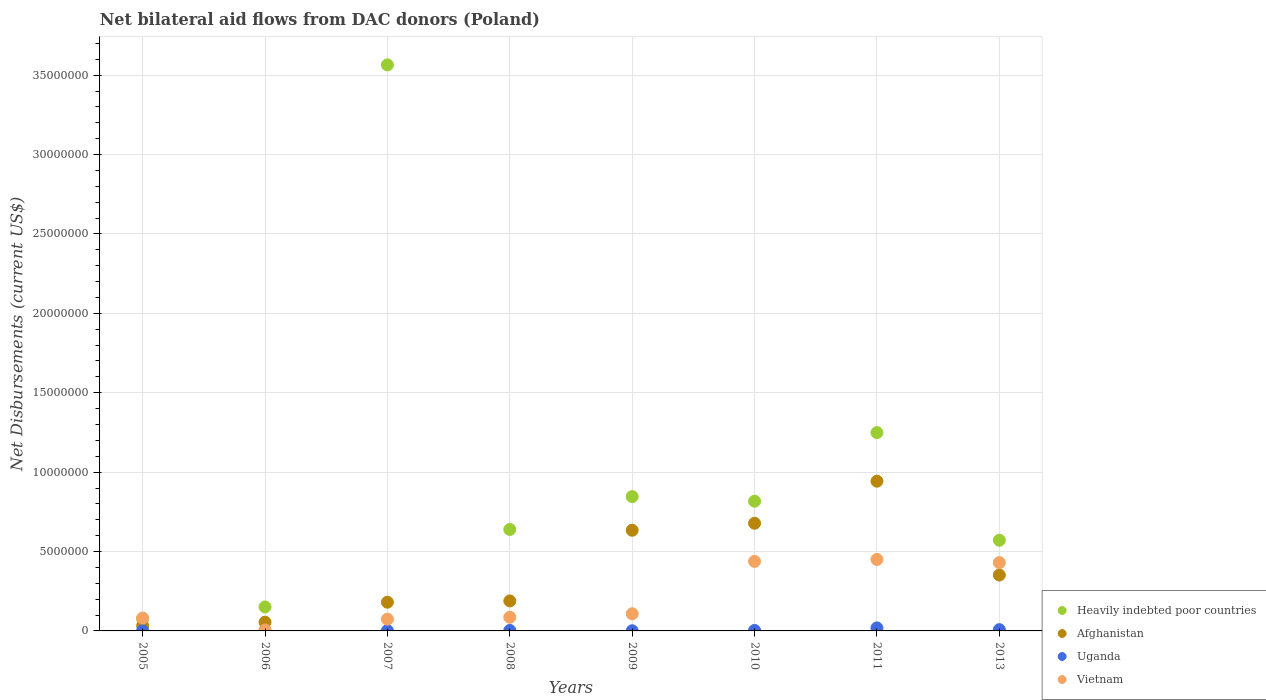Is the number of dotlines equal to the number of legend labels?
Keep it short and to the point. Yes. What is the net bilateral aid flows in Vietnam in 2010?
Ensure brevity in your answer.  4.38e+06. Across all years, what is the maximum net bilateral aid flows in Vietnam?
Offer a very short reply. 4.50e+06. Across all years, what is the minimum net bilateral aid flows in Afghanistan?
Make the answer very short. 3.30e+05. In which year was the net bilateral aid flows in Afghanistan maximum?
Ensure brevity in your answer.  2011. What is the total net bilateral aid flows in Vietnam in the graph?
Your response must be concise. 1.67e+07. What is the difference between the net bilateral aid flows in Uganda in 2011 and that in 2013?
Your answer should be very brief. 1.10e+05. What is the difference between the net bilateral aid flows in Afghanistan in 2011 and the net bilateral aid flows in Vietnam in 2007?
Make the answer very short. 8.69e+06. What is the average net bilateral aid flows in Afghanistan per year?
Offer a very short reply. 3.83e+06. In the year 2007, what is the difference between the net bilateral aid flows in Afghanistan and net bilateral aid flows in Vietnam?
Your response must be concise. 1.07e+06. What is the ratio of the net bilateral aid flows in Afghanistan in 2007 to that in 2008?
Your response must be concise. 0.96. Is the difference between the net bilateral aid flows in Afghanistan in 2008 and 2010 greater than the difference between the net bilateral aid flows in Vietnam in 2008 and 2010?
Keep it short and to the point. No. What is the difference between the highest and the second highest net bilateral aid flows in Uganda?
Keep it short and to the point. 1.10e+05. What is the difference between the highest and the lowest net bilateral aid flows in Uganda?
Your answer should be compact. 1.80e+05. Is it the case that in every year, the sum of the net bilateral aid flows in Uganda and net bilateral aid flows in Afghanistan  is greater than the sum of net bilateral aid flows in Heavily indebted poor countries and net bilateral aid flows in Vietnam?
Provide a short and direct response. No. Is it the case that in every year, the sum of the net bilateral aid flows in Heavily indebted poor countries and net bilateral aid flows in Afghanistan  is greater than the net bilateral aid flows in Uganda?
Keep it short and to the point. Yes. Does the net bilateral aid flows in Heavily indebted poor countries monotonically increase over the years?
Your response must be concise. No. Is the net bilateral aid flows in Vietnam strictly greater than the net bilateral aid flows in Uganda over the years?
Your answer should be very brief. Yes. How many dotlines are there?
Keep it short and to the point. 4. What is the difference between two consecutive major ticks on the Y-axis?
Your response must be concise. 5.00e+06. Are the values on the major ticks of Y-axis written in scientific E-notation?
Your response must be concise. No. Does the graph contain grids?
Your answer should be compact. Yes. Where does the legend appear in the graph?
Your answer should be compact. Bottom right. How are the legend labels stacked?
Provide a succinct answer. Vertical. What is the title of the graph?
Offer a very short reply. Net bilateral aid flows from DAC donors (Poland). What is the label or title of the X-axis?
Provide a short and direct response. Years. What is the label or title of the Y-axis?
Offer a terse response. Net Disbursements (current US$). What is the Net Disbursements (current US$) of Heavily indebted poor countries in 2005?
Make the answer very short. 7.60e+05. What is the Net Disbursements (current US$) in Afghanistan in 2005?
Your answer should be compact. 3.30e+05. What is the Net Disbursements (current US$) of Uganda in 2005?
Offer a very short reply. 10000. What is the Net Disbursements (current US$) in Vietnam in 2005?
Offer a very short reply. 8.10e+05. What is the Net Disbursements (current US$) of Heavily indebted poor countries in 2006?
Your response must be concise. 1.51e+06. What is the Net Disbursements (current US$) in Uganda in 2006?
Your answer should be very brief. 10000. What is the Net Disbursements (current US$) of Vietnam in 2006?
Provide a succinct answer. 6.00e+04. What is the Net Disbursements (current US$) in Heavily indebted poor countries in 2007?
Ensure brevity in your answer.  3.56e+07. What is the Net Disbursements (current US$) in Afghanistan in 2007?
Your response must be concise. 1.81e+06. What is the Net Disbursements (current US$) in Uganda in 2007?
Offer a terse response. 2.00e+04. What is the Net Disbursements (current US$) in Vietnam in 2007?
Provide a short and direct response. 7.40e+05. What is the Net Disbursements (current US$) of Heavily indebted poor countries in 2008?
Provide a short and direct response. 6.39e+06. What is the Net Disbursements (current US$) of Afghanistan in 2008?
Provide a short and direct response. 1.89e+06. What is the Net Disbursements (current US$) in Uganda in 2008?
Your response must be concise. 3.00e+04. What is the Net Disbursements (current US$) in Vietnam in 2008?
Provide a short and direct response. 8.60e+05. What is the Net Disbursements (current US$) of Heavily indebted poor countries in 2009?
Your response must be concise. 8.46e+06. What is the Net Disbursements (current US$) in Afghanistan in 2009?
Offer a terse response. 6.34e+06. What is the Net Disbursements (current US$) of Uganda in 2009?
Your answer should be very brief. 10000. What is the Net Disbursements (current US$) of Vietnam in 2009?
Provide a succinct answer. 1.08e+06. What is the Net Disbursements (current US$) of Heavily indebted poor countries in 2010?
Ensure brevity in your answer.  8.17e+06. What is the Net Disbursements (current US$) in Afghanistan in 2010?
Your answer should be very brief. 6.78e+06. What is the Net Disbursements (current US$) of Uganda in 2010?
Provide a short and direct response. 3.00e+04. What is the Net Disbursements (current US$) in Vietnam in 2010?
Your response must be concise. 4.38e+06. What is the Net Disbursements (current US$) of Heavily indebted poor countries in 2011?
Offer a terse response. 1.25e+07. What is the Net Disbursements (current US$) of Afghanistan in 2011?
Offer a terse response. 9.43e+06. What is the Net Disbursements (current US$) in Uganda in 2011?
Offer a very short reply. 1.90e+05. What is the Net Disbursements (current US$) of Vietnam in 2011?
Your answer should be compact. 4.50e+06. What is the Net Disbursements (current US$) in Heavily indebted poor countries in 2013?
Offer a terse response. 5.71e+06. What is the Net Disbursements (current US$) of Afghanistan in 2013?
Provide a short and direct response. 3.52e+06. What is the Net Disbursements (current US$) of Vietnam in 2013?
Your response must be concise. 4.30e+06. Across all years, what is the maximum Net Disbursements (current US$) of Heavily indebted poor countries?
Offer a very short reply. 3.56e+07. Across all years, what is the maximum Net Disbursements (current US$) in Afghanistan?
Give a very brief answer. 9.43e+06. Across all years, what is the maximum Net Disbursements (current US$) in Vietnam?
Make the answer very short. 4.50e+06. Across all years, what is the minimum Net Disbursements (current US$) of Heavily indebted poor countries?
Provide a succinct answer. 7.60e+05. Across all years, what is the minimum Net Disbursements (current US$) in Uganda?
Ensure brevity in your answer.  10000. Across all years, what is the minimum Net Disbursements (current US$) in Vietnam?
Offer a terse response. 6.00e+04. What is the total Net Disbursements (current US$) in Heavily indebted poor countries in the graph?
Your answer should be compact. 7.91e+07. What is the total Net Disbursements (current US$) in Afghanistan in the graph?
Ensure brevity in your answer.  3.06e+07. What is the total Net Disbursements (current US$) of Uganda in the graph?
Provide a short and direct response. 3.80e+05. What is the total Net Disbursements (current US$) in Vietnam in the graph?
Give a very brief answer. 1.67e+07. What is the difference between the Net Disbursements (current US$) in Heavily indebted poor countries in 2005 and that in 2006?
Provide a short and direct response. -7.50e+05. What is the difference between the Net Disbursements (current US$) in Uganda in 2005 and that in 2006?
Provide a short and direct response. 0. What is the difference between the Net Disbursements (current US$) of Vietnam in 2005 and that in 2006?
Your response must be concise. 7.50e+05. What is the difference between the Net Disbursements (current US$) in Heavily indebted poor countries in 2005 and that in 2007?
Your response must be concise. -3.49e+07. What is the difference between the Net Disbursements (current US$) of Afghanistan in 2005 and that in 2007?
Provide a succinct answer. -1.48e+06. What is the difference between the Net Disbursements (current US$) in Heavily indebted poor countries in 2005 and that in 2008?
Offer a very short reply. -5.63e+06. What is the difference between the Net Disbursements (current US$) of Afghanistan in 2005 and that in 2008?
Give a very brief answer. -1.56e+06. What is the difference between the Net Disbursements (current US$) of Heavily indebted poor countries in 2005 and that in 2009?
Offer a terse response. -7.70e+06. What is the difference between the Net Disbursements (current US$) of Afghanistan in 2005 and that in 2009?
Your answer should be compact. -6.01e+06. What is the difference between the Net Disbursements (current US$) in Uganda in 2005 and that in 2009?
Provide a short and direct response. 0. What is the difference between the Net Disbursements (current US$) in Vietnam in 2005 and that in 2009?
Offer a very short reply. -2.70e+05. What is the difference between the Net Disbursements (current US$) of Heavily indebted poor countries in 2005 and that in 2010?
Your answer should be compact. -7.41e+06. What is the difference between the Net Disbursements (current US$) in Afghanistan in 2005 and that in 2010?
Provide a succinct answer. -6.45e+06. What is the difference between the Net Disbursements (current US$) of Vietnam in 2005 and that in 2010?
Provide a short and direct response. -3.57e+06. What is the difference between the Net Disbursements (current US$) in Heavily indebted poor countries in 2005 and that in 2011?
Your response must be concise. -1.17e+07. What is the difference between the Net Disbursements (current US$) in Afghanistan in 2005 and that in 2011?
Keep it short and to the point. -9.10e+06. What is the difference between the Net Disbursements (current US$) in Uganda in 2005 and that in 2011?
Give a very brief answer. -1.80e+05. What is the difference between the Net Disbursements (current US$) in Vietnam in 2005 and that in 2011?
Keep it short and to the point. -3.69e+06. What is the difference between the Net Disbursements (current US$) in Heavily indebted poor countries in 2005 and that in 2013?
Make the answer very short. -4.95e+06. What is the difference between the Net Disbursements (current US$) of Afghanistan in 2005 and that in 2013?
Keep it short and to the point. -3.19e+06. What is the difference between the Net Disbursements (current US$) of Vietnam in 2005 and that in 2013?
Your answer should be very brief. -3.49e+06. What is the difference between the Net Disbursements (current US$) of Heavily indebted poor countries in 2006 and that in 2007?
Make the answer very short. -3.41e+07. What is the difference between the Net Disbursements (current US$) in Afghanistan in 2006 and that in 2007?
Make the answer very short. -1.26e+06. What is the difference between the Net Disbursements (current US$) in Vietnam in 2006 and that in 2007?
Your response must be concise. -6.80e+05. What is the difference between the Net Disbursements (current US$) of Heavily indebted poor countries in 2006 and that in 2008?
Offer a very short reply. -4.88e+06. What is the difference between the Net Disbursements (current US$) in Afghanistan in 2006 and that in 2008?
Provide a succinct answer. -1.34e+06. What is the difference between the Net Disbursements (current US$) in Vietnam in 2006 and that in 2008?
Offer a terse response. -8.00e+05. What is the difference between the Net Disbursements (current US$) of Heavily indebted poor countries in 2006 and that in 2009?
Make the answer very short. -6.95e+06. What is the difference between the Net Disbursements (current US$) of Afghanistan in 2006 and that in 2009?
Your answer should be compact. -5.79e+06. What is the difference between the Net Disbursements (current US$) in Uganda in 2006 and that in 2009?
Your response must be concise. 0. What is the difference between the Net Disbursements (current US$) in Vietnam in 2006 and that in 2009?
Your answer should be compact. -1.02e+06. What is the difference between the Net Disbursements (current US$) of Heavily indebted poor countries in 2006 and that in 2010?
Offer a very short reply. -6.66e+06. What is the difference between the Net Disbursements (current US$) in Afghanistan in 2006 and that in 2010?
Offer a very short reply. -6.23e+06. What is the difference between the Net Disbursements (current US$) of Uganda in 2006 and that in 2010?
Offer a very short reply. -2.00e+04. What is the difference between the Net Disbursements (current US$) in Vietnam in 2006 and that in 2010?
Your answer should be very brief. -4.32e+06. What is the difference between the Net Disbursements (current US$) of Heavily indebted poor countries in 2006 and that in 2011?
Your answer should be very brief. -1.10e+07. What is the difference between the Net Disbursements (current US$) of Afghanistan in 2006 and that in 2011?
Keep it short and to the point. -8.88e+06. What is the difference between the Net Disbursements (current US$) of Vietnam in 2006 and that in 2011?
Your answer should be very brief. -4.44e+06. What is the difference between the Net Disbursements (current US$) of Heavily indebted poor countries in 2006 and that in 2013?
Offer a very short reply. -4.20e+06. What is the difference between the Net Disbursements (current US$) in Afghanistan in 2006 and that in 2013?
Ensure brevity in your answer.  -2.97e+06. What is the difference between the Net Disbursements (current US$) of Vietnam in 2006 and that in 2013?
Make the answer very short. -4.24e+06. What is the difference between the Net Disbursements (current US$) of Heavily indebted poor countries in 2007 and that in 2008?
Your answer should be compact. 2.93e+07. What is the difference between the Net Disbursements (current US$) in Afghanistan in 2007 and that in 2008?
Keep it short and to the point. -8.00e+04. What is the difference between the Net Disbursements (current US$) of Uganda in 2007 and that in 2008?
Keep it short and to the point. -10000. What is the difference between the Net Disbursements (current US$) in Vietnam in 2007 and that in 2008?
Provide a succinct answer. -1.20e+05. What is the difference between the Net Disbursements (current US$) in Heavily indebted poor countries in 2007 and that in 2009?
Your answer should be compact. 2.72e+07. What is the difference between the Net Disbursements (current US$) of Afghanistan in 2007 and that in 2009?
Keep it short and to the point. -4.53e+06. What is the difference between the Net Disbursements (current US$) in Uganda in 2007 and that in 2009?
Your answer should be very brief. 10000. What is the difference between the Net Disbursements (current US$) in Heavily indebted poor countries in 2007 and that in 2010?
Offer a very short reply. 2.75e+07. What is the difference between the Net Disbursements (current US$) of Afghanistan in 2007 and that in 2010?
Provide a short and direct response. -4.97e+06. What is the difference between the Net Disbursements (current US$) of Vietnam in 2007 and that in 2010?
Provide a succinct answer. -3.64e+06. What is the difference between the Net Disbursements (current US$) in Heavily indebted poor countries in 2007 and that in 2011?
Provide a short and direct response. 2.32e+07. What is the difference between the Net Disbursements (current US$) of Afghanistan in 2007 and that in 2011?
Provide a short and direct response. -7.62e+06. What is the difference between the Net Disbursements (current US$) of Uganda in 2007 and that in 2011?
Your answer should be compact. -1.70e+05. What is the difference between the Net Disbursements (current US$) in Vietnam in 2007 and that in 2011?
Your response must be concise. -3.76e+06. What is the difference between the Net Disbursements (current US$) of Heavily indebted poor countries in 2007 and that in 2013?
Provide a succinct answer. 2.99e+07. What is the difference between the Net Disbursements (current US$) of Afghanistan in 2007 and that in 2013?
Offer a very short reply. -1.71e+06. What is the difference between the Net Disbursements (current US$) in Vietnam in 2007 and that in 2013?
Give a very brief answer. -3.56e+06. What is the difference between the Net Disbursements (current US$) of Heavily indebted poor countries in 2008 and that in 2009?
Your answer should be very brief. -2.07e+06. What is the difference between the Net Disbursements (current US$) in Afghanistan in 2008 and that in 2009?
Provide a succinct answer. -4.45e+06. What is the difference between the Net Disbursements (current US$) in Uganda in 2008 and that in 2009?
Ensure brevity in your answer.  2.00e+04. What is the difference between the Net Disbursements (current US$) of Heavily indebted poor countries in 2008 and that in 2010?
Your answer should be compact. -1.78e+06. What is the difference between the Net Disbursements (current US$) of Afghanistan in 2008 and that in 2010?
Give a very brief answer. -4.89e+06. What is the difference between the Net Disbursements (current US$) in Uganda in 2008 and that in 2010?
Offer a terse response. 0. What is the difference between the Net Disbursements (current US$) of Vietnam in 2008 and that in 2010?
Ensure brevity in your answer.  -3.52e+06. What is the difference between the Net Disbursements (current US$) of Heavily indebted poor countries in 2008 and that in 2011?
Your answer should be very brief. -6.10e+06. What is the difference between the Net Disbursements (current US$) of Afghanistan in 2008 and that in 2011?
Offer a terse response. -7.54e+06. What is the difference between the Net Disbursements (current US$) in Uganda in 2008 and that in 2011?
Provide a succinct answer. -1.60e+05. What is the difference between the Net Disbursements (current US$) of Vietnam in 2008 and that in 2011?
Your answer should be compact. -3.64e+06. What is the difference between the Net Disbursements (current US$) in Heavily indebted poor countries in 2008 and that in 2013?
Your answer should be compact. 6.80e+05. What is the difference between the Net Disbursements (current US$) in Afghanistan in 2008 and that in 2013?
Your answer should be compact. -1.63e+06. What is the difference between the Net Disbursements (current US$) of Uganda in 2008 and that in 2013?
Give a very brief answer. -5.00e+04. What is the difference between the Net Disbursements (current US$) in Vietnam in 2008 and that in 2013?
Your response must be concise. -3.44e+06. What is the difference between the Net Disbursements (current US$) of Afghanistan in 2009 and that in 2010?
Keep it short and to the point. -4.40e+05. What is the difference between the Net Disbursements (current US$) in Uganda in 2009 and that in 2010?
Your answer should be compact. -2.00e+04. What is the difference between the Net Disbursements (current US$) of Vietnam in 2009 and that in 2010?
Give a very brief answer. -3.30e+06. What is the difference between the Net Disbursements (current US$) in Heavily indebted poor countries in 2009 and that in 2011?
Give a very brief answer. -4.03e+06. What is the difference between the Net Disbursements (current US$) of Afghanistan in 2009 and that in 2011?
Keep it short and to the point. -3.09e+06. What is the difference between the Net Disbursements (current US$) of Vietnam in 2009 and that in 2011?
Your answer should be compact. -3.42e+06. What is the difference between the Net Disbursements (current US$) in Heavily indebted poor countries in 2009 and that in 2013?
Provide a short and direct response. 2.75e+06. What is the difference between the Net Disbursements (current US$) of Afghanistan in 2009 and that in 2013?
Keep it short and to the point. 2.82e+06. What is the difference between the Net Disbursements (current US$) in Uganda in 2009 and that in 2013?
Your answer should be very brief. -7.00e+04. What is the difference between the Net Disbursements (current US$) of Vietnam in 2009 and that in 2013?
Keep it short and to the point. -3.22e+06. What is the difference between the Net Disbursements (current US$) of Heavily indebted poor countries in 2010 and that in 2011?
Your answer should be compact. -4.32e+06. What is the difference between the Net Disbursements (current US$) of Afghanistan in 2010 and that in 2011?
Offer a terse response. -2.65e+06. What is the difference between the Net Disbursements (current US$) in Heavily indebted poor countries in 2010 and that in 2013?
Provide a succinct answer. 2.46e+06. What is the difference between the Net Disbursements (current US$) in Afghanistan in 2010 and that in 2013?
Your answer should be compact. 3.26e+06. What is the difference between the Net Disbursements (current US$) in Vietnam in 2010 and that in 2013?
Ensure brevity in your answer.  8.00e+04. What is the difference between the Net Disbursements (current US$) in Heavily indebted poor countries in 2011 and that in 2013?
Provide a short and direct response. 6.78e+06. What is the difference between the Net Disbursements (current US$) in Afghanistan in 2011 and that in 2013?
Offer a terse response. 5.91e+06. What is the difference between the Net Disbursements (current US$) in Uganda in 2011 and that in 2013?
Give a very brief answer. 1.10e+05. What is the difference between the Net Disbursements (current US$) in Vietnam in 2011 and that in 2013?
Your response must be concise. 2.00e+05. What is the difference between the Net Disbursements (current US$) of Heavily indebted poor countries in 2005 and the Net Disbursements (current US$) of Uganda in 2006?
Offer a terse response. 7.50e+05. What is the difference between the Net Disbursements (current US$) of Heavily indebted poor countries in 2005 and the Net Disbursements (current US$) of Afghanistan in 2007?
Your answer should be very brief. -1.05e+06. What is the difference between the Net Disbursements (current US$) of Heavily indebted poor countries in 2005 and the Net Disbursements (current US$) of Uganda in 2007?
Give a very brief answer. 7.40e+05. What is the difference between the Net Disbursements (current US$) in Heavily indebted poor countries in 2005 and the Net Disbursements (current US$) in Vietnam in 2007?
Provide a succinct answer. 2.00e+04. What is the difference between the Net Disbursements (current US$) of Afghanistan in 2005 and the Net Disbursements (current US$) of Uganda in 2007?
Give a very brief answer. 3.10e+05. What is the difference between the Net Disbursements (current US$) of Afghanistan in 2005 and the Net Disbursements (current US$) of Vietnam in 2007?
Offer a very short reply. -4.10e+05. What is the difference between the Net Disbursements (current US$) in Uganda in 2005 and the Net Disbursements (current US$) in Vietnam in 2007?
Your answer should be very brief. -7.30e+05. What is the difference between the Net Disbursements (current US$) of Heavily indebted poor countries in 2005 and the Net Disbursements (current US$) of Afghanistan in 2008?
Offer a very short reply. -1.13e+06. What is the difference between the Net Disbursements (current US$) of Heavily indebted poor countries in 2005 and the Net Disbursements (current US$) of Uganda in 2008?
Ensure brevity in your answer.  7.30e+05. What is the difference between the Net Disbursements (current US$) of Heavily indebted poor countries in 2005 and the Net Disbursements (current US$) of Vietnam in 2008?
Your answer should be compact. -1.00e+05. What is the difference between the Net Disbursements (current US$) in Afghanistan in 2005 and the Net Disbursements (current US$) in Uganda in 2008?
Offer a terse response. 3.00e+05. What is the difference between the Net Disbursements (current US$) of Afghanistan in 2005 and the Net Disbursements (current US$) of Vietnam in 2008?
Ensure brevity in your answer.  -5.30e+05. What is the difference between the Net Disbursements (current US$) in Uganda in 2005 and the Net Disbursements (current US$) in Vietnam in 2008?
Offer a terse response. -8.50e+05. What is the difference between the Net Disbursements (current US$) of Heavily indebted poor countries in 2005 and the Net Disbursements (current US$) of Afghanistan in 2009?
Provide a succinct answer. -5.58e+06. What is the difference between the Net Disbursements (current US$) in Heavily indebted poor countries in 2005 and the Net Disbursements (current US$) in Uganda in 2009?
Your answer should be compact. 7.50e+05. What is the difference between the Net Disbursements (current US$) in Heavily indebted poor countries in 2005 and the Net Disbursements (current US$) in Vietnam in 2009?
Give a very brief answer. -3.20e+05. What is the difference between the Net Disbursements (current US$) of Afghanistan in 2005 and the Net Disbursements (current US$) of Vietnam in 2009?
Ensure brevity in your answer.  -7.50e+05. What is the difference between the Net Disbursements (current US$) in Uganda in 2005 and the Net Disbursements (current US$) in Vietnam in 2009?
Ensure brevity in your answer.  -1.07e+06. What is the difference between the Net Disbursements (current US$) in Heavily indebted poor countries in 2005 and the Net Disbursements (current US$) in Afghanistan in 2010?
Make the answer very short. -6.02e+06. What is the difference between the Net Disbursements (current US$) in Heavily indebted poor countries in 2005 and the Net Disbursements (current US$) in Uganda in 2010?
Offer a very short reply. 7.30e+05. What is the difference between the Net Disbursements (current US$) of Heavily indebted poor countries in 2005 and the Net Disbursements (current US$) of Vietnam in 2010?
Your response must be concise. -3.62e+06. What is the difference between the Net Disbursements (current US$) in Afghanistan in 2005 and the Net Disbursements (current US$) in Uganda in 2010?
Provide a short and direct response. 3.00e+05. What is the difference between the Net Disbursements (current US$) in Afghanistan in 2005 and the Net Disbursements (current US$) in Vietnam in 2010?
Keep it short and to the point. -4.05e+06. What is the difference between the Net Disbursements (current US$) of Uganda in 2005 and the Net Disbursements (current US$) of Vietnam in 2010?
Offer a terse response. -4.37e+06. What is the difference between the Net Disbursements (current US$) of Heavily indebted poor countries in 2005 and the Net Disbursements (current US$) of Afghanistan in 2011?
Your answer should be compact. -8.67e+06. What is the difference between the Net Disbursements (current US$) of Heavily indebted poor countries in 2005 and the Net Disbursements (current US$) of Uganda in 2011?
Give a very brief answer. 5.70e+05. What is the difference between the Net Disbursements (current US$) in Heavily indebted poor countries in 2005 and the Net Disbursements (current US$) in Vietnam in 2011?
Your answer should be compact. -3.74e+06. What is the difference between the Net Disbursements (current US$) of Afghanistan in 2005 and the Net Disbursements (current US$) of Vietnam in 2011?
Offer a terse response. -4.17e+06. What is the difference between the Net Disbursements (current US$) in Uganda in 2005 and the Net Disbursements (current US$) in Vietnam in 2011?
Ensure brevity in your answer.  -4.49e+06. What is the difference between the Net Disbursements (current US$) in Heavily indebted poor countries in 2005 and the Net Disbursements (current US$) in Afghanistan in 2013?
Give a very brief answer. -2.76e+06. What is the difference between the Net Disbursements (current US$) of Heavily indebted poor countries in 2005 and the Net Disbursements (current US$) of Uganda in 2013?
Provide a short and direct response. 6.80e+05. What is the difference between the Net Disbursements (current US$) in Heavily indebted poor countries in 2005 and the Net Disbursements (current US$) in Vietnam in 2013?
Keep it short and to the point. -3.54e+06. What is the difference between the Net Disbursements (current US$) in Afghanistan in 2005 and the Net Disbursements (current US$) in Vietnam in 2013?
Your response must be concise. -3.97e+06. What is the difference between the Net Disbursements (current US$) of Uganda in 2005 and the Net Disbursements (current US$) of Vietnam in 2013?
Your response must be concise. -4.29e+06. What is the difference between the Net Disbursements (current US$) of Heavily indebted poor countries in 2006 and the Net Disbursements (current US$) of Afghanistan in 2007?
Your answer should be compact. -3.00e+05. What is the difference between the Net Disbursements (current US$) in Heavily indebted poor countries in 2006 and the Net Disbursements (current US$) in Uganda in 2007?
Offer a terse response. 1.49e+06. What is the difference between the Net Disbursements (current US$) in Heavily indebted poor countries in 2006 and the Net Disbursements (current US$) in Vietnam in 2007?
Ensure brevity in your answer.  7.70e+05. What is the difference between the Net Disbursements (current US$) in Afghanistan in 2006 and the Net Disbursements (current US$) in Uganda in 2007?
Ensure brevity in your answer.  5.30e+05. What is the difference between the Net Disbursements (current US$) of Uganda in 2006 and the Net Disbursements (current US$) of Vietnam in 2007?
Your answer should be compact. -7.30e+05. What is the difference between the Net Disbursements (current US$) in Heavily indebted poor countries in 2006 and the Net Disbursements (current US$) in Afghanistan in 2008?
Provide a succinct answer. -3.80e+05. What is the difference between the Net Disbursements (current US$) in Heavily indebted poor countries in 2006 and the Net Disbursements (current US$) in Uganda in 2008?
Your answer should be very brief. 1.48e+06. What is the difference between the Net Disbursements (current US$) in Heavily indebted poor countries in 2006 and the Net Disbursements (current US$) in Vietnam in 2008?
Offer a terse response. 6.50e+05. What is the difference between the Net Disbursements (current US$) in Afghanistan in 2006 and the Net Disbursements (current US$) in Uganda in 2008?
Your answer should be very brief. 5.20e+05. What is the difference between the Net Disbursements (current US$) in Afghanistan in 2006 and the Net Disbursements (current US$) in Vietnam in 2008?
Offer a very short reply. -3.10e+05. What is the difference between the Net Disbursements (current US$) in Uganda in 2006 and the Net Disbursements (current US$) in Vietnam in 2008?
Your answer should be very brief. -8.50e+05. What is the difference between the Net Disbursements (current US$) of Heavily indebted poor countries in 2006 and the Net Disbursements (current US$) of Afghanistan in 2009?
Give a very brief answer. -4.83e+06. What is the difference between the Net Disbursements (current US$) of Heavily indebted poor countries in 2006 and the Net Disbursements (current US$) of Uganda in 2009?
Offer a terse response. 1.50e+06. What is the difference between the Net Disbursements (current US$) in Heavily indebted poor countries in 2006 and the Net Disbursements (current US$) in Vietnam in 2009?
Give a very brief answer. 4.30e+05. What is the difference between the Net Disbursements (current US$) in Afghanistan in 2006 and the Net Disbursements (current US$) in Uganda in 2009?
Make the answer very short. 5.40e+05. What is the difference between the Net Disbursements (current US$) in Afghanistan in 2006 and the Net Disbursements (current US$) in Vietnam in 2009?
Your answer should be very brief. -5.30e+05. What is the difference between the Net Disbursements (current US$) of Uganda in 2006 and the Net Disbursements (current US$) of Vietnam in 2009?
Make the answer very short. -1.07e+06. What is the difference between the Net Disbursements (current US$) of Heavily indebted poor countries in 2006 and the Net Disbursements (current US$) of Afghanistan in 2010?
Make the answer very short. -5.27e+06. What is the difference between the Net Disbursements (current US$) in Heavily indebted poor countries in 2006 and the Net Disbursements (current US$) in Uganda in 2010?
Offer a very short reply. 1.48e+06. What is the difference between the Net Disbursements (current US$) in Heavily indebted poor countries in 2006 and the Net Disbursements (current US$) in Vietnam in 2010?
Make the answer very short. -2.87e+06. What is the difference between the Net Disbursements (current US$) of Afghanistan in 2006 and the Net Disbursements (current US$) of Uganda in 2010?
Provide a succinct answer. 5.20e+05. What is the difference between the Net Disbursements (current US$) in Afghanistan in 2006 and the Net Disbursements (current US$) in Vietnam in 2010?
Provide a short and direct response. -3.83e+06. What is the difference between the Net Disbursements (current US$) in Uganda in 2006 and the Net Disbursements (current US$) in Vietnam in 2010?
Keep it short and to the point. -4.37e+06. What is the difference between the Net Disbursements (current US$) of Heavily indebted poor countries in 2006 and the Net Disbursements (current US$) of Afghanistan in 2011?
Provide a succinct answer. -7.92e+06. What is the difference between the Net Disbursements (current US$) of Heavily indebted poor countries in 2006 and the Net Disbursements (current US$) of Uganda in 2011?
Offer a very short reply. 1.32e+06. What is the difference between the Net Disbursements (current US$) in Heavily indebted poor countries in 2006 and the Net Disbursements (current US$) in Vietnam in 2011?
Ensure brevity in your answer.  -2.99e+06. What is the difference between the Net Disbursements (current US$) of Afghanistan in 2006 and the Net Disbursements (current US$) of Uganda in 2011?
Offer a very short reply. 3.60e+05. What is the difference between the Net Disbursements (current US$) of Afghanistan in 2006 and the Net Disbursements (current US$) of Vietnam in 2011?
Your answer should be compact. -3.95e+06. What is the difference between the Net Disbursements (current US$) in Uganda in 2006 and the Net Disbursements (current US$) in Vietnam in 2011?
Offer a terse response. -4.49e+06. What is the difference between the Net Disbursements (current US$) in Heavily indebted poor countries in 2006 and the Net Disbursements (current US$) in Afghanistan in 2013?
Keep it short and to the point. -2.01e+06. What is the difference between the Net Disbursements (current US$) of Heavily indebted poor countries in 2006 and the Net Disbursements (current US$) of Uganda in 2013?
Your answer should be very brief. 1.43e+06. What is the difference between the Net Disbursements (current US$) in Heavily indebted poor countries in 2006 and the Net Disbursements (current US$) in Vietnam in 2013?
Keep it short and to the point. -2.79e+06. What is the difference between the Net Disbursements (current US$) in Afghanistan in 2006 and the Net Disbursements (current US$) in Vietnam in 2013?
Offer a very short reply. -3.75e+06. What is the difference between the Net Disbursements (current US$) of Uganda in 2006 and the Net Disbursements (current US$) of Vietnam in 2013?
Make the answer very short. -4.29e+06. What is the difference between the Net Disbursements (current US$) of Heavily indebted poor countries in 2007 and the Net Disbursements (current US$) of Afghanistan in 2008?
Give a very brief answer. 3.38e+07. What is the difference between the Net Disbursements (current US$) of Heavily indebted poor countries in 2007 and the Net Disbursements (current US$) of Uganda in 2008?
Provide a short and direct response. 3.56e+07. What is the difference between the Net Disbursements (current US$) in Heavily indebted poor countries in 2007 and the Net Disbursements (current US$) in Vietnam in 2008?
Make the answer very short. 3.48e+07. What is the difference between the Net Disbursements (current US$) of Afghanistan in 2007 and the Net Disbursements (current US$) of Uganda in 2008?
Ensure brevity in your answer.  1.78e+06. What is the difference between the Net Disbursements (current US$) in Afghanistan in 2007 and the Net Disbursements (current US$) in Vietnam in 2008?
Give a very brief answer. 9.50e+05. What is the difference between the Net Disbursements (current US$) of Uganda in 2007 and the Net Disbursements (current US$) of Vietnam in 2008?
Make the answer very short. -8.40e+05. What is the difference between the Net Disbursements (current US$) in Heavily indebted poor countries in 2007 and the Net Disbursements (current US$) in Afghanistan in 2009?
Your response must be concise. 2.93e+07. What is the difference between the Net Disbursements (current US$) in Heavily indebted poor countries in 2007 and the Net Disbursements (current US$) in Uganda in 2009?
Ensure brevity in your answer.  3.56e+07. What is the difference between the Net Disbursements (current US$) of Heavily indebted poor countries in 2007 and the Net Disbursements (current US$) of Vietnam in 2009?
Offer a terse response. 3.46e+07. What is the difference between the Net Disbursements (current US$) of Afghanistan in 2007 and the Net Disbursements (current US$) of Uganda in 2009?
Provide a short and direct response. 1.80e+06. What is the difference between the Net Disbursements (current US$) in Afghanistan in 2007 and the Net Disbursements (current US$) in Vietnam in 2009?
Provide a short and direct response. 7.30e+05. What is the difference between the Net Disbursements (current US$) in Uganda in 2007 and the Net Disbursements (current US$) in Vietnam in 2009?
Your answer should be compact. -1.06e+06. What is the difference between the Net Disbursements (current US$) in Heavily indebted poor countries in 2007 and the Net Disbursements (current US$) in Afghanistan in 2010?
Ensure brevity in your answer.  2.89e+07. What is the difference between the Net Disbursements (current US$) in Heavily indebted poor countries in 2007 and the Net Disbursements (current US$) in Uganda in 2010?
Offer a very short reply. 3.56e+07. What is the difference between the Net Disbursements (current US$) in Heavily indebted poor countries in 2007 and the Net Disbursements (current US$) in Vietnam in 2010?
Offer a very short reply. 3.13e+07. What is the difference between the Net Disbursements (current US$) in Afghanistan in 2007 and the Net Disbursements (current US$) in Uganda in 2010?
Provide a short and direct response. 1.78e+06. What is the difference between the Net Disbursements (current US$) of Afghanistan in 2007 and the Net Disbursements (current US$) of Vietnam in 2010?
Give a very brief answer. -2.57e+06. What is the difference between the Net Disbursements (current US$) in Uganda in 2007 and the Net Disbursements (current US$) in Vietnam in 2010?
Give a very brief answer. -4.36e+06. What is the difference between the Net Disbursements (current US$) in Heavily indebted poor countries in 2007 and the Net Disbursements (current US$) in Afghanistan in 2011?
Provide a short and direct response. 2.62e+07. What is the difference between the Net Disbursements (current US$) in Heavily indebted poor countries in 2007 and the Net Disbursements (current US$) in Uganda in 2011?
Your response must be concise. 3.55e+07. What is the difference between the Net Disbursements (current US$) in Heavily indebted poor countries in 2007 and the Net Disbursements (current US$) in Vietnam in 2011?
Offer a very short reply. 3.12e+07. What is the difference between the Net Disbursements (current US$) in Afghanistan in 2007 and the Net Disbursements (current US$) in Uganda in 2011?
Make the answer very short. 1.62e+06. What is the difference between the Net Disbursements (current US$) of Afghanistan in 2007 and the Net Disbursements (current US$) of Vietnam in 2011?
Give a very brief answer. -2.69e+06. What is the difference between the Net Disbursements (current US$) in Uganda in 2007 and the Net Disbursements (current US$) in Vietnam in 2011?
Make the answer very short. -4.48e+06. What is the difference between the Net Disbursements (current US$) of Heavily indebted poor countries in 2007 and the Net Disbursements (current US$) of Afghanistan in 2013?
Provide a short and direct response. 3.21e+07. What is the difference between the Net Disbursements (current US$) of Heavily indebted poor countries in 2007 and the Net Disbursements (current US$) of Uganda in 2013?
Ensure brevity in your answer.  3.56e+07. What is the difference between the Net Disbursements (current US$) of Heavily indebted poor countries in 2007 and the Net Disbursements (current US$) of Vietnam in 2013?
Make the answer very short. 3.14e+07. What is the difference between the Net Disbursements (current US$) of Afghanistan in 2007 and the Net Disbursements (current US$) of Uganda in 2013?
Offer a terse response. 1.73e+06. What is the difference between the Net Disbursements (current US$) of Afghanistan in 2007 and the Net Disbursements (current US$) of Vietnam in 2013?
Keep it short and to the point. -2.49e+06. What is the difference between the Net Disbursements (current US$) of Uganda in 2007 and the Net Disbursements (current US$) of Vietnam in 2013?
Your answer should be very brief. -4.28e+06. What is the difference between the Net Disbursements (current US$) in Heavily indebted poor countries in 2008 and the Net Disbursements (current US$) in Afghanistan in 2009?
Your answer should be very brief. 5.00e+04. What is the difference between the Net Disbursements (current US$) of Heavily indebted poor countries in 2008 and the Net Disbursements (current US$) of Uganda in 2009?
Keep it short and to the point. 6.38e+06. What is the difference between the Net Disbursements (current US$) of Heavily indebted poor countries in 2008 and the Net Disbursements (current US$) of Vietnam in 2009?
Your response must be concise. 5.31e+06. What is the difference between the Net Disbursements (current US$) in Afghanistan in 2008 and the Net Disbursements (current US$) in Uganda in 2009?
Make the answer very short. 1.88e+06. What is the difference between the Net Disbursements (current US$) of Afghanistan in 2008 and the Net Disbursements (current US$) of Vietnam in 2009?
Offer a terse response. 8.10e+05. What is the difference between the Net Disbursements (current US$) of Uganda in 2008 and the Net Disbursements (current US$) of Vietnam in 2009?
Offer a terse response. -1.05e+06. What is the difference between the Net Disbursements (current US$) of Heavily indebted poor countries in 2008 and the Net Disbursements (current US$) of Afghanistan in 2010?
Your response must be concise. -3.90e+05. What is the difference between the Net Disbursements (current US$) of Heavily indebted poor countries in 2008 and the Net Disbursements (current US$) of Uganda in 2010?
Ensure brevity in your answer.  6.36e+06. What is the difference between the Net Disbursements (current US$) of Heavily indebted poor countries in 2008 and the Net Disbursements (current US$) of Vietnam in 2010?
Offer a terse response. 2.01e+06. What is the difference between the Net Disbursements (current US$) in Afghanistan in 2008 and the Net Disbursements (current US$) in Uganda in 2010?
Your answer should be compact. 1.86e+06. What is the difference between the Net Disbursements (current US$) in Afghanistan in 2008 and the Net Disbursements (current US$) in Vietnam in 2010?
Your response must be concise. -2.49e+06. What is the difference between the Net Disbursements (current US$) in Uganda in 2008 and the Net Disbursements (current US$) in Vietnam in 2010?
Offer a terse response. -4.35e+06. What is the difference between the Net Disbursements (current US$) in Heavily indebted poor countries in 2008 and the Net Disbursements (current US$) in Afghanistan in 2011?
Keep it short and to the point. -3.04e+06. What is the difference between the Net Disbursements (current US$) of Heavily indebted poor countries in 2008 and the Net Disbursements (current US$) of Uganda in 2011?
Make the answer very short. 6.20e+06. What is the difference between the Net Disbursements (current US$) in Heavily indebted poor countries in 2008 and the Net Disbursements (current US$) in Vietnam in 2011?
Keep it short and to the point. 1.89e+06. What is the difference between the Net Disbursements (current US$) in Afghanistan in 2008 and the Net Disbursements (current US$) in Uganda in 2011?
Offer a terse response. 1.70e+06. What is the difference between the Net Disbursements (current US$) in Afghanistan in 2008 and the Net Disbursements (current US$) in Vietnam in 2011?
Ensure brevity in your answer.  -2.61e+06. What is the difference between the Net Disbursements (current US$) in Uganda in 2008 and the Net Disbursements (current US$) in Vietnam in 2011?
Provide a succinct answer. -4.47e+06. What is the difference between the Net Disbursements (current US$) of Heavily indebted poor countries in 2008 and the Net Disbursements (current US$) of Afghanistan in 2013?
Your answer should be compact. 2.87e+06. What is the difference between the Net Disbursements (current US$) in Heavily indebted poor countries in 2008 and the Net Disbursements (current US$) in Uganda in 2013?
Provide a succinct answer. 6.31e+06. What is the difference between the Net Disbursements (current US$) in Heavily indebted poor countries in 2008 and the Net Disbursements (current US$) in Vietnam in 2013?
Provide a succinct answer. 2.09e+06. What is the difference between the Net Disbursements (current US$) in Afghanistan in 2008 and the Net Disbursements (current US$) in Uganda in 2013?
Provide a short and direct response. 1.81e+06. What is the difference between the Net Disbursements (current US$) in Afghanistan in 2008 and the Net Disbursements (current US$) in Vietnam in 2013?
Your response must be concise. -2.41e+06. What is the difference between the Net Disbursements (current US$) of Uganda in 2008 and the Net Disbursements (current US$) of Vietnam in 2013?
Provide a succinct answer. -4.27e+06. What is the difference between the Net Disbursements (current US$) in Heavily indebted poor countries in 2009 and the Net Disbursements (current US$) in Afghanistan in 2010?
Offer a very short reply. 1.68e+06. What is the difference between the Net Disbursements (current US$) in Heavily indebted poor countries in 2009 and the Net Disbursements (current US$) in Uganda in 2010?
Offer a terse response. 8.43e+06. What is the difference between the Net Disbursements (current US$) in Heavily indebted poor countries in 2009 and the Net Disbursements (current US$) in Vietnam in 2010?
Your answer should be compact. 4.08e+06. What is the difference between the Net Disbursements (current US$) of Afghanistan in 2009 and the Net Disbursements (current US$) of Uganda in 2010?
Keep it short and to the point. 6.31e+06. What is the difference between the Net Disbursements (current US$) in Afghanistan in 2009 and the Net Disbursements (current US$) in Vietnam in 2010?
Make the answer very short. 1.96e+06. What is the difference between the Net Disbursements (current US$) in Uganda in 2009 and the Net Disbursements (current US$) in Vietnam in 2010?
Your response must be concise. -4.37e+06. What is the difference between the Net Disbursements (current US$) of Heavily indebted poor countries in 2009 and the Net Disbursements (current US$) of Afghanistan in 2011?
Provide a short and direct response. -9.70e+05. What is the difference between the Net Disbursements (current US$) of Heavily indebted poor countries in 2009 and the Net Disbursements (current US$) of Uganda in 2011?
Give a very brief answer. 8.27e+06. What is the difference between the Net Disbursements (current US$) in Heavily indebted poor countries in 2009 and the Net Disbursements (current US$) in Vietnam in 2011?
Ensure brevity in your answer.  3.96e+06. What is the difference between the Net Disbursements (current US$) in Afghanistan in 2009 and the Net Disbursements (current US$) in Uganda in 2011?
Your answer should be very brief. 6.15e+06. What is the difference between the Net Disbursements (current US$) of Afghanistan in 2009 and the Net Disbursements (current US$) of Vietnam in 2011?
Give a very brief answer. 1.84e+06. What is the difference between the Net Disbursements (current US$) of Uganda in 2009 and the Net Disbursements (current US$) of Vietnam in 2011?
Give a very brief answer. -4.49e+06. What is the difference between the Net Disbursements (current US$) in Heavily indebted poor countries in 2009 and the Net Disbursements (current US$) in Afghanistan in 2013?
Provide a succinct answer. 4.94e+06. What is the difference between the Net Disbursements (current US$) in Heavily indebted poor countries in 2009 and the Net Disbursements (current US$) in Uganda in 2013?
Your answer should be compact. 8.38e+06. What is the difference between the Net Disbursements (current US$) of Heavily indebted poor countries in 2009 and the Net Disbursements (current US$) of Vietnam in 2013?
Your response must be concise. 4.16e+06. What is the difference between the Net Disbursements (current US$) of Afghanistan in 2009 and the Net Disbursements (current US$) of Uganda in 2013?
Provide a short and direct response. 6.26e+06. What is the difference between the Net Disbursements (current US$) in Afghanistan in 2009 and the Net Disbursements (current US$) in Vietnam in 2013?
Give a very brief answer. 2.04e+06. What is the difference between the Net Disbursements (current US$) in Uganda in 2009 and the Net Disbursements (current US$) in Vietnam in 2013?
Keep it short and to the point. -4.29e+06. What is the difference between the Net Disbursements (current US$) of Heavily indebted poor countries in 2010 and the Net Disbursements (current US$) of Afghanistan in 2011?
Offer a terse response. -1.26e+06. What is the difference between the Net Disbursements (current US$) in Heavily indebted poor countries in 2010 and the Net Disbursements (current US$) in Uganda in 2011?
Your answer should be compact. 7.98e+06. What is the difference between the Net Disbursements (current US$) of Heavily indebted poor countries in 2010 and the Net Disbursements (current US$) of Vietnam in 2011?
Your answer should be compact. 3.67e+06. What is the difference between the Net Disbursements (current US$) in Afghanistan in 2010 and the Net Disbursements (current US$) in Uganda in 2011?
Provide a short and direct response. 6.59e+06. What is the difference between the Net Disbursements (current US$) of Afghanistan in 2010 and the Net Disbursements (current US$) of Vietnam in 2011?
Make the answer very short. 2.28e+06. What is the difference between the Net Disbursements (current US$) of Uganda in 2010 and the Net Disbursements (current US$) of Vietnam in 2011?
Keep it short and to the point. -4.47e+06. What is the difference between the Net Disbursements (current US$) in Heavily indebted poor countries in 2010 and the Net Disbursements (current US$) in Afghanistan in 2013?
Provide a succinct answer. 4.65e+06. What is the difference between the Net Disbursements (current US$) in Heavily indebted poor countries in 2010 and the Net Disbursements (current US$) in Uganda in 2013?
Your answer should be very brief. 8.09e+06. What is the difference between the Net Disbursements (current US$) of Heavily indebted poor countries in 2010 and the Net Disbursements (current US$) of Vietnam in 2013?
Ensure brevity in your answer.  3.87e+06. What is the difference between the Net Disbursements (current US$) of Afghanistan in 2010 and the Net Disbursements (current US$) of Uganda in 2013?
Your response must be concise. 6.70e+06. What is the difference between the Net Disbursements (current US$) in Afghanistan in 2010 and the Net Disbursements (current US$) in Vietnam in 2013?
Keep it short and to the point. 2.48e+06. What is the difference between the Net Disbursements (current US$) in Uganda in 2010 and the Net Disbursements (current US$) in Vietnam in 2013?
Give a very brief answer. -4.27e+06. What is the difference between the Net Disbursements (current US$) of Heavily indebted poor countries in 2011 and the Net Disbursements (current US$) of Afghanistan in 2013?
Keep it short and to the point. 8.97e+06. What is the difference between the Net Disbursements (current US$) of Heavily indebted poor countries in 2011 and the Net Disbursements (current US$) of Uganda in 2013?
Your answer should be compact. 1.24e+07. What is the difference between the Net Disbursements (current US$) of Heavily indebted poor countries in 2011 and the Net Disbursements (current US$) of Vietnam in 2013?
Give a very brief answer. 8.19e+06. What is the difference between the Net Disbursements (current US$) of Afghanistan in 2011 and the Net Disbursements (current US$) of Uganda in 2013?
Your answer should be very brief. 9.35e+06. What is the difference between the Net Disbursements (current US$) of Afghanistan in 2011 and the Net Disbursements (current US$) of Vietnam in 2013?
Offer a terse response. 5.13e+06. What is the difference between the Net Disbursements (current US$) in Uganda in 2011 and the Net Disbursements (current US$) in Vietnam in 2013?
Provide a succinct answer. -4.11e+06. What is the average Net Disbursements (current US$) in Heavily indebted poor countries per year?
Your answer should be compact. 9.89e+06. What is the average Net Disbursements (current US$) in Afghanistan per year?
Keep it short and to the point. 3.83e+06. What is the average Net Disbursements (current US$) in Uganda per year?
Your answer should be very brief. 4.75e+04. What is the average Net Disbursements (current US$) in Vietnam per year?
Offer a terse response. 2.09e+06. In the year 2005, what is the difference between the Net Disbursements (current US$) of Heavily indebted poor countries and Net Disbursements (current US$) of Afghanistan?
Your answer should be compact. 4.30e+05. In the year 2005, what is the difference between the Net Disbursements (current US$) of Heavily indebted poor countries and Net Disbursements (current US$) of Uganda?
Make the answer very short. 7.50e+05. In the year 2005, what is the difference between the Net Disbursements (current US$) of Heavily indebted poor countries and Net Disbursements (current US$) of Vietnam?
Keep it short and to the point. -5.00e+04. In the year 2005, what is the difference between the Net Disbursements (current US$) in Afghanistan and Net Disbursements (current US$) in Vietnam?
Offer a very short reply. -4.80e+05. In the year 2005, what is the difference between the Net Disbursements (current US$) of Uganda and Net Disbursements (current US$) of Vietnam?
Your answer should be very brief. -8.00e+05. In the year 2006, what is the difference between the Net Disbursements (current US$) in Heavily indebted poor countries and Net Disbursements (current US$) in Afghanistan?
Your answer should be very brief. 9.60e+05. In the year 2006, what is the difference between the Net Disbursements (current US$) of Heavily indebted poor countries and Net Disbursements (current US$) of Uganda?
Offer a very short reply. 1.50e+06. In the year 2006, what is the difference between the Net Disbursements (current US$) in Heavily indebted poor countries and Net Disbursements (current US$) in Vietnam?
Provide a short and direct response. 1.45e+06. In the year 2006, what is the difference between the Net Disbursements (current US$) of Afghanistan and Net Disbursements (current US$) of Uganda?
Offer a terse response. 5.40e+05. In the year 2006, what is the difference between the Net Disbursements (current US$) in Afghanistan and Net Disbursements (current US$) in Vietnam?
Your answer should be very brief. 4.90e+05. In the year 2007, what is the difference between the Net Disbursements (current US$) in Heavily indebted poor countries and Net Disbursements (current US$) in Afghanistan?
Offer a very short reply. 3.38e+07. In the year 2007, what is the difference between the Net Disbursements (current US$) in Heavily indebted poor countries and Net Disbursements (current US$) in Uganda?
Ensure brevity in your answer.  3.56e+07. In the year 2007, what is the difference between the Net Disbursements (current US$) in Heavily indebted poor countries and Net Disbursements (current US$) in Vietnam?
Provide a succinct answer. 3.49e+07. In the year 2007, what is the difference between the Net Disbursements (current US$) of Afghanistan and Net Disbursements (current US$) of Uganda?
Make the answer very short. 1.79e+06. In the year 2007, what is the difference between the Net Disbursements (current US$) of Afghanistan and Net Disbursements (current US$) of Vietnam?
Provide a short and direct response. 1.07e+06. In the year 2007, what is the difference between the Net Disbursements (current US$) of Uganda and Net Disbursements (current US$) of Vietnam?
Ensure brevity in your answer.  -7.20e+05. In the year 2008, what is the difference between the Net Disbursements (current US$) of Heavily indebted poor countries and Net Disbursements (current US$) of Afghanistan?
Keep it short and to the point. 4.50e+06. In the year 2008, what is the difference between the Net Disbursements (current US$) of Heavily indebted poor countries and Net Disbursements (current US$) of Uganda?
Offer a very short reply. 6.36e+06. In the year 2008, what is the difference between the Net Disbursements (current US$) in Heavily indebted poor countries and Net Disbursements (current US$) in Vietnam?
Give a very brief answer. 5.53e+06. In the year 2008, what is the difference between the Net Disbursements (current US$) in Afghanistan and Net Disbursements (current US$) in Uganda?
Make the answer very short. 1.86e+06. In the year 2008, what is the difference between the Net Disbursements (current US$) in Afghanistan and Net Disbursements (current US$) in Vietnam?
Your response must be concise. 1.03e+06. In the year 2008, what is the difference between the Net Disbursements (current US$) of Uganda and Net Disbursements (current US$) of Vietnam?
Provide a succinct answer. -8.30e+05. In the year 2009, what is the difference between the Net Disbursements (current US$) in Heavily indebted poor countries and Net Disbursements (current US$) in Afghanistan?
Your answer should be compact. 2.12e+06. In the year 2009, what is the difference between the Net Disbursements (current US$) in Heavily indebted poor countries and Net Disbursements (current US$) in Uganda?
Keep it short and to the point. 8.45e+06. In the year 2009, what is the difference between the Net Disbursements (current US$) of Heavily indebted poor countries and Net Disbursements (current US$) of Vietnam?
Make the answer very short. 7.38e+06. In the year 2009, what is the difference between the Net Disbursements (current US$) of Afghanistan and Net Disbursements (current US$) of Uganda?
Provide a short and direct response. 6.33e+06. In the year 2009, what is the difference between the Net Disbursements (current US$) of Afghanistan and Net Disbursements (current US$) of Vietnam?
Give a very brief answer. 5.26e+06. In the year 2009, what is the difference between the Net Disbursements (current US$) in Uganda and Net Disbursements (current US$) in Vietnam?
Offer a very short reply. -1.07e+06. In the year 2010, what is the difference between the Net Disbursements (current US$) of Heavily indebted poor countries and Net Disbursements (current US$) of Afghanistan?
Your answer should be compact. 1.39e+06. In the year 2010, what is the difference between the Net Disbursements (current US$) in Heavily indebted poor countries and Net Disbursements (current US$) in Uganda?
Offer a terse response. 8.14e+06. In the year 2010, what is the difference between the Net Disbursements (current US$) of Heavily indebted poor countries and Net Disbursements (current US$) of Vietnam?
Your response must be concise. 3.79e+06. In the year 2010, what is the difference between the Net Disbursements (current US$) in Afghanistan and Net Disbursements (current US$) in Uganda?
Your response must be concise. 6.75e+06. In the year 2010, what is the difference between the Net Disbursements (current US$) of Afghanistan and Net Disbursements (current US$) of Vietnam?
Offer a terse response. 2.40e+06. In the year 2010, what is the difference between the Net Disbursements (current US$) in Uganda and Net Disbursements (current US$) in Vietnam?
Provide a short and direct response. -4.35e+06. In the year 2011, what is the difference between the Net Disbursements (current US$) in Heavily indebted poor countries and Net Disbursements (current US$) in Afghanistan?
Provide a succinct answer. 3.06e+06. In the year 2011, what is the difference between the Net Disbursements (current US$) in Heavily indebted poor countries and Net Disbursements (current US$) in Uganda?
Keep it short and to the point. 1.23e+07. In the year 2011, what is the difference between the Net Disbursements (current US$) of Heavily indebted poor countries and Net Disbursements (current US$) of Vietnam?
Offer a very short reply. 7.99e+06. In the year 2011, what is the difference between the Net Disbursements (current US$) in Afghanistan and Net Disbursements (current US$) in Uganda?
Provide a short and direct response. 9.24e+06. In the year 2011, what is the difference between the Net Disbursements (current US$) of Afghanistan and Net Disbursements (current US$) of Vietnam?
Keep it short and to the point. 4.93e+06. In the year 2011, what is the difference between the Net Disbursements (current US$) in Uganda and Net Disbursements (current US$) in Vietnam?
Provide a succinct answer. -4.31e+06. In the year 2013, what is the difference between the Net Disbursements (current US$) of Heavily indebted poor countries and Net Disbursements (current US$) of Afghanistan?
Your response must be concise. 2.19e+06. In the year 2013, what is the difference between the Net Disbursements (current US$) in Heavily indebted poor countries and Net Disbursements (current US$) in Uganda?
Your response must be concise. 5.63e+06. In the year 2013, what is the difference between the Net Disbursements (current US$) of Heavily indebted poor countries and Net Disbursements (current US$) of Vietnam?
Your answer should be very brief. 1.41e+06. In the year 2013, what is the difference between the Net Disbursements (current US$) of Afghanistan and Net Disbursements (current US$) of Uganda?
Provide a succinct answer. 3.44e+06. In the year 2013, what is the difference between the Net Disbursements (current US$) of Afghanistan and Net Disbursements (current US$) of Vietnam?
Offer a terse response. -7.80e+05. In the year 2013, what is the difference between the Net Disbursements (current US$) of Uganda and Net Disbursements (current US$) of Vietnam?
Make the answer very short. -4.22e+06. What is the ratio of the Net Disbursements (current US$) in Heavily indebted poor countries in 2005 to that in 2006?
Provide a short and direct response. 0.5. What is the ratio of the Net Disbursements (current US$) in Afghanistan in 2005 to that in 2006?
Provide a short and direct response. 0.6. What is the ratio of the Net Disbursements (current US$) of Uganda in 2005 to that in 2006?
Provide a succinct answer. 1. What is the ratio of the Net Disbursements (current US$) in Heavily indebted poor countries in 2005 to that in 2007?
Offer a very short reply. 0.02. What is the ratio of the Net Disbursements (current US$) in Afghanistan in 2005 to that in 2007?
Keep it short and to the point. 0.18. What is the ratio of the Net Disbursements (current US$) of Vietnam in 2005 to that in 2007?
Provide a short and direct response. 1.09. What is the ratio of the Net Disbursements (current US$) of Heavily indebted poor countries in 2005 to that in 2008?
Offer a terse response. 0.12. What is the ratio of the Net Disbursements (current US$) of Afghanistan in 2005 to that in 2008?
Your response must be concise. 0.17. What is the ratio of the Net Disbursements (current US$) in Uganda in 2005 to that in 2008?
Keep it short and to the point. 0.33. What is the ratio of the Net Disbursements (current US$) in Vietnam in 2005 to that in 2008?
Give a very brief answer. 0.94. What is the ratio of the Net Disbursements (current US$) in Heavily indebted poor countries in 2005 to that in 2009?
Your response must be concise. 0.09. What is the ratio of the Net Disbursements (current US$) of Afghanistan in 2005 to that in 2009?
Provide a succinct answer. 0.05. What is the ratio of the Net Disbursements (current US$) in Uganda in 2005 to that in 2009?
Ensure brevity in your answer.  1. What is the ratio of the Net Disbursements (current US$) of Vietnam in 2005 to that in 2009?
Keep it short and to the point. 0.75. What is the ratio of the Net Disbursements (current US$) of Heavily indebted poor countries in 2005 to that in 2010?
Keep it short and to the point. 0.09. What is the ratio of the Net Disbursements (current US$) in Afghanistan in 2005 to that in 2010?
Provide a succinct answer. 0.05. What is the ratio of the Net Disbursements (current US$) in Vietnam in 2005 to that in 2010?
Make the answer very short. 0.18. What is the ratio of the Net Disbursements (current US$) of Heavily indebted poor countries in 2005 to that in 2011?
Your answer should be very brief. 0.06. What is the ratio of the Net Disbursements (current US$) in Afghanistan in 2005 to that in 2011?
Make the answer very short. 0.04. What is the ratio of the Net Disbursements (current US$) in Uganda in 2005 to that in 2011?
Offer a terse response. 0.05. What is the ratio of the Net Disbursements (current US$) in Vietnam in 2005 to that in 2011?
Offer a very short reply. 0.18. What is the ratio of the Net Disbursements (current US$) of Heavily indebted poor countries in 2005 to that in 2013?
Give a very brief answer. 0.13. What is the ratio of the Net Disbursements (current US$) of Afghanistan in 2005 to that in 2013?
Offer a terse response. 0.09. What is the ratio of the Net Disbursements (current US$) of Uganda in 2005 to that in 2013?
Your answer should be compact. 0.12. What is the ratio of the Net Disbursements (current US$) in Vietnam in 2005 to that in 2013?
Provide a short and direct response. 0.19. What is the ratio of the Net Disbursements (current US$) in Heavily indebted poor countries in 2006 to that in 2007?
Offer a very short reply. 0.04. What is the ratio of the Net Disbursements (current US$) in Afghanistan in 2006 to that in 2007?
Provide a succinct answer. 0.3. What is the ratio of the Net Disbursements (current US$) of Uganda in 2006 to that in 2007?
Offer a very short reply. 0.5. What is the ratio of the Net Disbursements (current US$) in Vietnam in 2006 to that in 2007?
Offer a very short reply. 0.08. What is the ratio of the Net Disbursements (current US$) in Heavily indebted poor countries in 2006 to that in 2008?
Keep it short and to the point. 0.24. What is the ratio of the Net Disbursements (current US$) of Afghanistan in 2006 to that in 2008?
Your answer should be very brief. 0.29. What is the ratio of the Net Disbursements (current US$) in Vietnam in 2006 to that in 2008?
Your answer should be very brief. 0.07. What is the ratio of the Net Disbursements (current US$) in Heavily indebted poor countries in 2006 to that in 2009?
Offer a very short reply. 0.18. What is the ratio of the Net Disbursements (current US$) of Afghanistan in 2006 to that in 2009?
Ensure brevity in your answer.  0.09. What is the ratio of the Net Disbursements (current US$) of Uganda in 2006 to that in 2009?
Your answer should be compact. 1. What is the ratio of the Net Disbursements (current US$) of Vietnam in 2006 to that in 2009?
Your answer should be compact. 0.06. What is the ratio of the Net Disbursements (current US$) in Heavily indebted poor countries in 2006 to that in 2010?
Offer a terse response. 0.18. What is the ratio of the Net Disbursements (current US$) of Afghanistan in 2006 to that in 2010?
Offer a terse response. 0.08. What is the ratio of the Net Disbursements (current US$) in Uganda in 2006 to that in 2010?
Offer a very short reply. 0.33. What is the ratio of the Net Disbursements (current US$) of Vietnam in 2006 to that in 2010?
Give a very brief answer. 0.01. What is the ratio of the Net Disbursements (current US$) in Heavily indebted poor countries in 2006 to that in 2011?
Make the answer very short. 0.12. What is the ratio of the Net Disbursements (current US$) of Afghanistan in 2006 to that in 2011?
Your response must be concise. 0.06. What is the ratio of the Net Disbursements (current US$) in Uganda in 2006 to that in 2011?
Ensure brevity in your answer.  0.05. What is the ratio of the Net Disbursements (current US$) in Vietnam in 2006 to that in 2011?
Offer a terse response. 0.01. What is the ratio of the Net Disbursements (current US$) of Heavily indebted poor countries in 2006 to that in 2013?
Your response must be concise. 0.26. What is the ratio of the Net Disbursements (current US$) in Afghanistan in 2006 to that in 2013?
Provide a succinct answer. 0.16. What is the ratio of the Net Disbursements (current US$) in Vietnam in 2006 to that in 2013?
Offer a very short reply. 0.01. What is the ratio of the Net Disbursements (current US$) in Heavily indebted poor countries in 2007 to that in 2008?
Your response must be concise. 5.58. What is the ratio of the Net Disbursements (current US$) in Afghanistan in 2007 to that in 2008?
Provide a short and direct response. 0.96. What is the ratio of the Net Disbursements (current US$) in Vietnam in 2007 to that in 2008?
Provide a succinct answer. 0.86. What is the ratio of the Net Disbursements (current US$) of Heavily indebted poor countries in 2007 to that in 2009?
Your answer should be very brief. 4.21. What is the ratio of the Net Disbursements (current US$) of Afghanistan in 2007 to that in 2009?
Keep it short and to the point. 0.29. What is the ratio of the Net Disbursements (current US$) of Uganda in 2007 to that in 2009?
Provide a succinct answer. 2. What is the ratio of the Net Disbursements (current US$) of Vietnam in 2007 to that in 2009?
Offer a terse response. 0.69. What is the ratio of the Net Disbursements (current US$) in Heavily indebted poor countries in 2007 to that in 2010?
Provide a succinct answer. 4.36. What is the ratio of the Net Disbursements (current US$) in Afghanistan in 2007 to that in 2010?
Make the answer very short. 0.27. What is the ratio of the Net Disbursements (current US$) of Uganda in 2007 to that in 2010?
Provide a short and direct response. 0.67. What is the ratio of the Net Disbursements (current US$) in Vietnam in 2007 to that in 2010?
Your response must be concise. 0.17. What is the ratio of the Net Disbursements (current US$) in Heavily indebted poor countries in 2007 to that in 2011?
Provide a succinct answer. 2.85. What is the ratio of the Net Disbursements (current US$) of Afghanistan in 2007 to that in 2011?
Give a very brief answer. 0.19. What is the ratio of the Net Disbursements (current US$) of Uganda in 2007 to that in 2011?
Your answer should be compact. 0.11. What is the ratio of the Net Disbursements (current US$) of Vietnam in 2007 to that in 2011?
Your answer should be very brief. 0.16. What is the ratio of the Net Disbursements (current US$) in Heavily indebted poor countries in 2007 to that in 2013?
Your answer should be compact. 6.24. What is the ratio of the Net Disbursements (current US$) in Afghanistan in 2007 to that in 2013?
Your answer should be compact. 0.51. What is the ratio of the Net Disbursements (current US$) of Uganda in 2007 to that in 2013?
Offer a terse response. 0.25. What is the ratio of the Net Disbursements (current US$) in Vietnam in 2007 to that in 2013?
Offer a terse response. 0.17. What is the ratio of the Net Disbursements (current US$) in Heavily indebted poor countries in 2008 to that in 2009?
Offer a very short reply. 0.76. What is the ratio of the Net Disbursements (current US$) of Afghanistan in 2008 to that in 2009?
Provide a succinct answer. 0.3. What is the ratio of the Net Disbursements (current US$) in Vietnam in 2008 to that in 2009?
Give a very brief answer. 0.8. What is the ratio of the Net Disbursements (current US$) in Heavily indebted poor countries in 2008 to that in 2010?
Your response must be concise. 0.78. What is the ratio of the Net Disbursements (current US$) in Afghanistan in 2008 to that in 2010?
Give a very brief answer. 0.28. What is the ratio of the Net Disbursements (current US$) of Vietnam in 2008 to that in 2010?
Ensure brevity in your answer.  0.2. What is the ratio of the Net Disbursements (current US$) of Heavily indebted poor countries in 2008 to that in 2011?
Your answer should be very brief. 0.51. What is the ratio of the Net Disbursements (current US$) of Afghanistan in 2008 to that in 2011?
Your answer should be compact. 0.2. What is the ratio of the Net Disbursements (current US$) in Uganda in 2008 to that in 2011?
Offer a terse response. 0.16. What is the ratio of the Net Disbursements (current US$) of Vietnam in 2008 to that in 2011?
Keep it short and to the point. 0.19. What is the ratio of the Net Disbursements (current US$) in Heavily indebted poor countries in 2008 to that in 2013?
Your response must be concise. 1.12. What is the ratio of the Net Disbursements (current US$) of Afghanistan in 2008 to that in 2013?
Give a very brief answer. 0.54. What is the ratio of the Net Disbursements (current US$) of Uganda in 2008 to that in 2013?
Keep it short and to the point. 0.38. What is the ratio of the Net Disbursements (current US$) of Vietnam in 2008 to that in 2013?
Your response must be concise. 0.2. What is the ratio of the Net Disbursements (current US$) in Heavily indebted poor countries in 2009 to that in 2010?
Your answer should be compact. 1.04. What is the ratio of the Net Disbursements (current US$) of Afghanistan in 2009 to that in 2010?
Provide a short and direct response. 0.94. What is the ratio of the Net Disbursements (current US$) of Uganda in 2009 to that in 2010?
Ensure brevity in your answer.  0.33. What is the ratio of the Net Disbursements (current US$) in Vietnam in 2009 to that in 2010?
Keep it short and to the point. 0.25. What is the ratio of the Net Disbursements (current US$) in Heavily indebted poor countries in 2009 to that in 2011?
Your answer should be very brief. 0.68. What is the ratio of the Net Disbursements (current US$) in Afghanistan in 2009 to that in 2011?
Give a very brief answer. 0.67. What is the ratio of the Net Disbursements (current US$) in Uganda in 2009 to that in 2011?
Your answer should be very brief. 0.05. What is the ratio of the Net Disbursements (current US$) of Vietnam in 2009 to that in 2011?
Provide a short and direct response. 0.24. What is the ratio of the Net Disbursements (current US$) of Heavily indebted poor countries in 2009 to that in 2013?
Offer a very short reply. 1.48. What is the ratio of the Net Disbursements (current US$) in Afghanistan in 2009 to that in 2013?
Offer a very short reply. 1.8. What is the ratio of the Net Disbursements (current US$) in Vietnam in 2009 to that in 2013?
Provide a succinct answer. 0.25. What is the ratio of the Net Disbursements (current US$) of Heavily indebted poor countries in 2010 to that in 2011?
Offer a terse response. 0.65. What is the ratio of the Net Disbursements (current US$) in Afghanistan in 2010 to that in 2011?
Give a very brief answer. 0.72. What is the ratio of the Net Disbursements (current US$) of Uganda in 2010 to that in 2011?
Give a very brief answer. 0.16. What is the ratio of the Net Disbursements (current US$) of Vietnam in 2010 to that in 2011?
Provide a short and direct response. 0.97. What is the ratio of the Net Disbursements (current US$) in Heavily indebted poor countries in 2010 to that in 2013?
Provide a succinct answer. 1.43. What is the ratio of the Net Disbursements (current US$) of Afghanistan in 2010 to that in 2013?
Keep it short and to the point. 1.93. What is the ratio of the Net Disbursements (current US$) in Vietnam in 2010 to that in 2013?
Provide a short and direct response. 1.02. What is the ratio of the Net Disbursements (current US$) in Heavily indebted poor countries in 2011 to that in 2013?
Provide a short and direct response. 2.19. What is the ratio of the Net Disbursements (current US$) of Afghanistan in 2011 to that in 2013?
Your answer should be very brief. 2.68. What is the ratio of the Net Disbursements (current US$) of Uganda in 2011 to that in 2013?
Provide a short and direct response. 2.38. What is the ratio of the Net Disbursements (current US$) in Vietnam in 2011 to that in 2013?
Your answer should be compact. 1.05. What is the difference between the highest and the second highest Net Disbursements (current US$) in Heavily indebted poor countries?
Give a very brief answer. 2.32e+07. What is the difference between the highest and the second highest Net Disbursements (current US$) in Afghanistan?
Provide a succinct answer. 2.65e+06. What is the difference between the highest and the second highest Net Disbursements (current US$) of Vietnam?
Provide a succinct answer. 1.20e+05. What is the difference between the highest and the lowest Net Disbursements (current US$) of Heavily indebted poor countries?
Ensure brevity in your answer.  3.49e+07. What is the difference between the highest and the lowest Net Disbursements (current US$) in Afghanistan?
Offer a very short reply. 9.10e+06. What is the difference between the highest and the lowest Net Disbursements (current US$) in Vietnam?
Offer a terse response. 4.44e+06. 